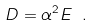<formula> <loc_0><loc_0><loc_500><loc_500>D = \alpha ^ { 2 } E \ .</formula> 